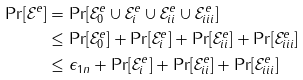Convert formula to latex. <formula><loc_0><loc_0><loc_500><loc_500>\Pr [ \mathcal { E } ^ { e } ] & = \Pr [ \mathcal { E } ^ { e } _ { 0 } \cup \mathcal { E } _ { i } ^ { e } \cup \mathcal { E } _ { i i } ^ { e } \cup \mathcal { E } _ { i i i } ^ { e } ] \\ & \leq \Pr [ \mathcal { E } ^ { e } _ { 0 } ] + \Pr [ \mathcal { E } _ { i } ^ { e } ] + \Pr [ \mathcal { E } _ { i i } ^ { e } ] + \Pr [ \mathcal { E } _ { i i i } ^ { e } ] \\ & \leq \epsilon _ { 1 n } + \Pr [ \mathcal { E } _ { i } ^ { e } ] + \Pr [ \mathcal { E } _ { i i } ^ { e } ] + \Pr [ \mathcal { E } _ { i i i } ^ { e } ]</formula> 